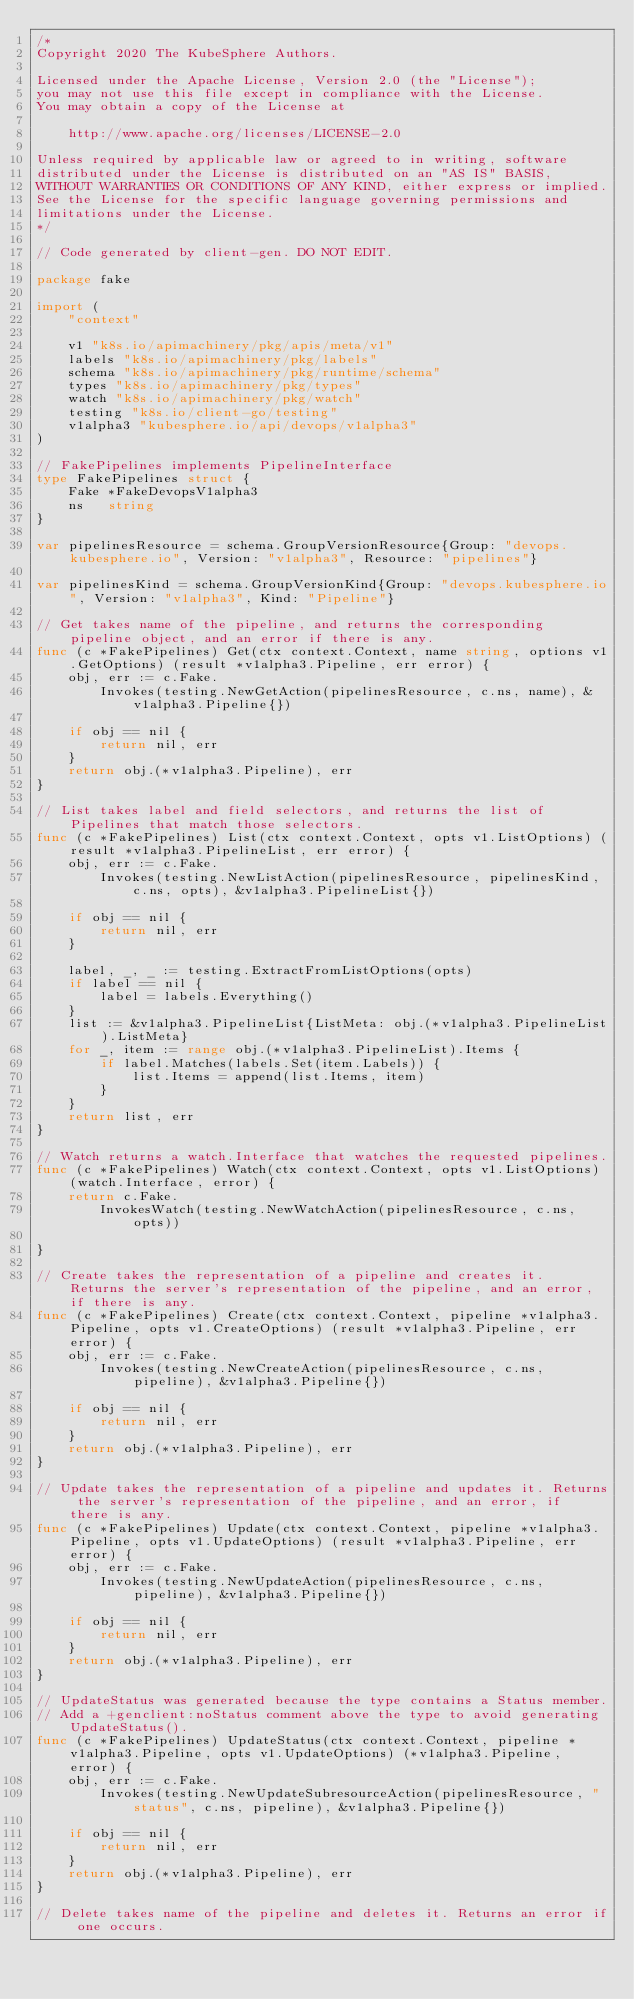Convert code to text. <code><loc_0><loc_0><loc_500><loc_500><_Go_>/*
Copyright 2020 The KubeSphere Authors.

Licensed under the Apache License, Version 2.0 (the "License");
you may not use this file except in compliance with the License.
You may obtain a copy of the License at

    http://www.apache.org/licenses/LICENSE-2.0

Unless required by applicable law or agreed to in writing, software
distributed under the License is distributed on an "AS IS" BASIS,
WITHOUT WARRANTIES OR CONDITIONS OF ANY KIND, either express or implied.
See the License for the specific language governing permissions and
limitations under the License.
*/

// Code generated by client-gen. DO NOT EDIT.

package fake

import (
	"context"

	v1 "k8s.io/apimachinery/pkg/apis/meta/v1"
	labels "k8s.io/apimachinery/pkg/labels"
	schema "k8s.io/apimachinery/pkg/runtime/schema"
	types "k8s.io/apimachinery/pkg/types"
	watch "k8s.io/apimachinery/pkg/watch"
	testing "k8s.io/client-go/testing"
	v1alpha3 "kubesphere.io/api/devops/v1alpha3"
)

// FakePipelines implements PipelineInterface
type FakePipelines struct {
	Fake *FakeDevopsV1alpha3
	ns   string
}

var pipelinesResource = schema.GroupVersionResource{Group: "devops.kubesphere.io", Version: "v1alpha3", Resource: "pipelines"}

var pipelinesKind = schema.GroupVersionKind{Group: "devops.kubesphere.io", Version: "v1alpha3", Kind: "Pipeline"}

// Get takes name of the pipeline, and returns the corresponding pipeline object, and an error if there is any.
func (c *FakePipelines) Get(ctx context.Context, name string, options v1.GetOptions) (result *v1alpha3.Pipeline, err error) {
	obj, err := c.Fake.
		Invokes(testing.NewGetAction(pipelinesResource, c.ns, name), &v1alpha3.Pipeline{})

	if obj == nil {
		return nil, err
	}
	return obj.(*v1alpha3.Pipeline), err
}

// List takes label and field selectors, and returns the list of Pipelines that match those selectors.
func (c *FakePipelines) List(ctx context.Context, opts v1.ListOptions) (result *v1alpha3.PipelineList, err error) {
	obj, err := c.Fake.
		Invokes(testing.NewListAction(pipelinesResource, pipelinesKind, c.ns, opts), &v1alpha3.PipelineList{})

	if obj == nil {
		return nil, err
	}

	label, _, _ := testing.ExtractFromListOptions(opts)
	if label == nil {
		label = labels.Everything()
	}
	list := &v1alpha3.PipelineList{ListMeta: obj.(*v1alpha3.PipelineList).ListMeta}
	for _, item := range obj.(*v1alpha3.PipelineList).Items {
		if label.Matches(labels.Set(item.Labels)) {
			list.Items = append(list.Items, item)
		}
	}
	return list, err
}

// Watch returns a watch.Interface that watches the requested pipelines.
func (c *FakePipelines) Watch(ctx context.Context, opts v1.ListOptions) (watch.Interface, error) {
	return c.Fake.
		InvokesWatch(testing.NewWatchAction(pipelinesResource, c.ns, opts))

}

// Create takes the representation of a pipeline and creates it.  Returns the server's representation of the pipeline, and an error, if there is any.
func (c *FakePipelines) Create(ctx context.Context, pipeline *v1alpha3.Pipeline, opts v1.CreateOptions) (result *v1alpha3.Pipeline, err error) {
	obj, err := c.Fake.
		Invokes(testing.NewCreateAction(pipelinesResource, c.ns, pipeline), &v1alpha3.Pipeline{})

	if obj == nil {
		return nil, err
	}
	return obj.(*v1alpha3.Pipeline), err
}

// Update takes the representation of a pipeline and updates it. Returns the server's representation of the pipeline, and an error, if there is any.
func (c *FakePipelines) Update(ctx context.Context, pipeline *v1alpha3.Pipeline, opts v1.UpdateOptions) (result *v1alpha3.Pipeline, err error) {
	obj, err := c.Fake.
		Invokes(testing.NewUpdateAction(pipelinesResource, c.ns, pipeline), &v1alpha3.Pipeline{})

	if obj == nil {
		return nil, err
	}
	return obj.(*v1alpha3.Pipeline), err
}

// UpdateStatus was generated because the type contains a Status member.
// Add a +genclient:noStatus comment above the type to avoid generating UpdateStatus().
func (c *FakePipelines) UpdateStatus(ctx context.Context, pipeline *v1alpha3.Pipeline, opts v1.UpdateOptions) (*v1alpha3.Pipeline, error) {
	obj, err := c.Fake.
		Invokes(testing.NewUpdateSubresourceAction(pipelinesResource, "status", c.ns, pipeline), &v1alpha3.Pipeline{})

	if obj == nil {
		return nil, err
	}
	return obj.(*v1alpha3.Pipeline), err
}

// Delete takes name of the pipeline and deletes it. Returns an error if one occurs.</code> 